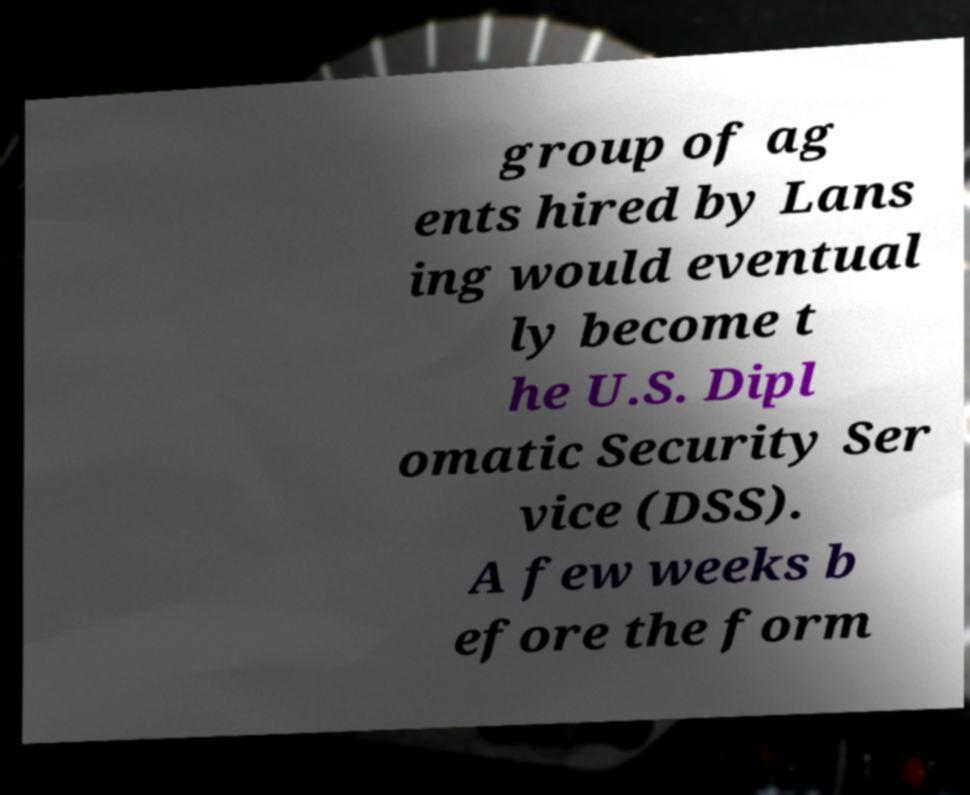There's text embedded in this image that I need extracted. Can you transcribe it verbatim? group of ag ents hired by Lans ing would eventual ly become t he U.S. Dipl omatic Security Ser vice (DSS). A few weeks b efore the form 